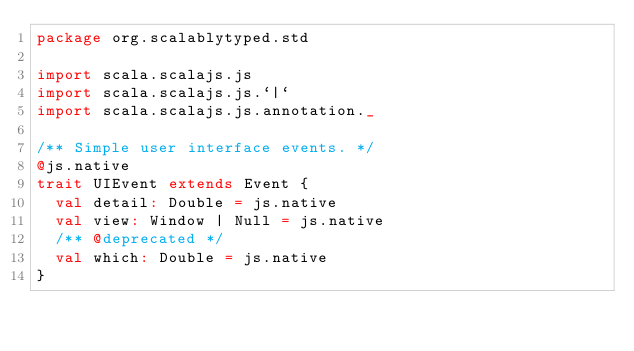Convert code to text. <code><loc_0><loc_0><loc_500><loc_500><_Scala_>package org.scalablytyped.std

import scala.scalajs.js
import scala.scalajs.js.`|`
import scala.scalajs.js.annotation._

/** Simple user interface events. */
@js.native
trait UIEvent extends Event {
  val detail: Double = js.native
  val view: Window | Null = js.native
  /** @deprecated */
  val which: Double = js.native
}

</code> 